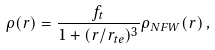<formula> <loc_0><loc_0><loc_500><loc_500>\rho ( r ) = \frac { f _ { t } } { 1 + ( r / r _ { t e } ) ^ { 3 } } \rho _ { N F W } ( r ) \, ,</formula> 